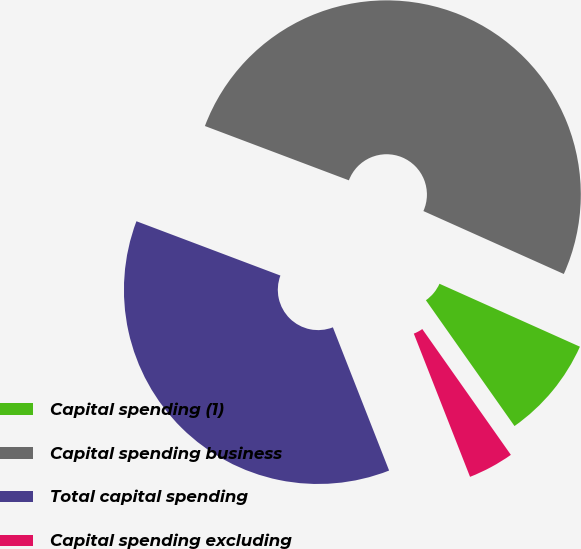Convert chart. <chart><loc_0><loc_0><loc_500><loc_500><pie_chart><fcel>Capital spending (1)<fcel>Capital spending business<fcel>Total capital spending<fcel>Capital spending excluding<nl><fcel>8.53%<fcel>50.97%<fcel>36.7%<fcel>3.81%<nl></chart> 